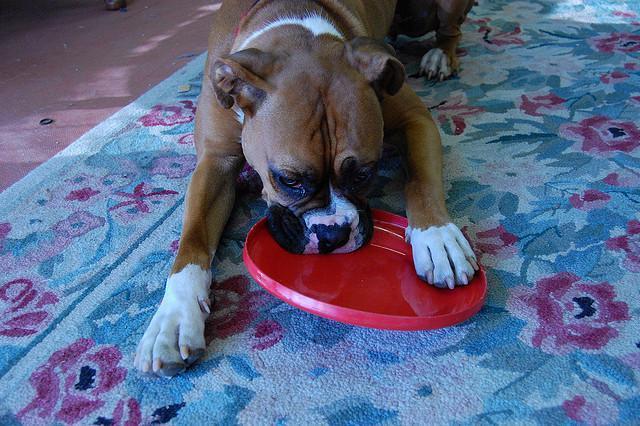How many suitcases in the photo?
Give a very brief answer. 0. 